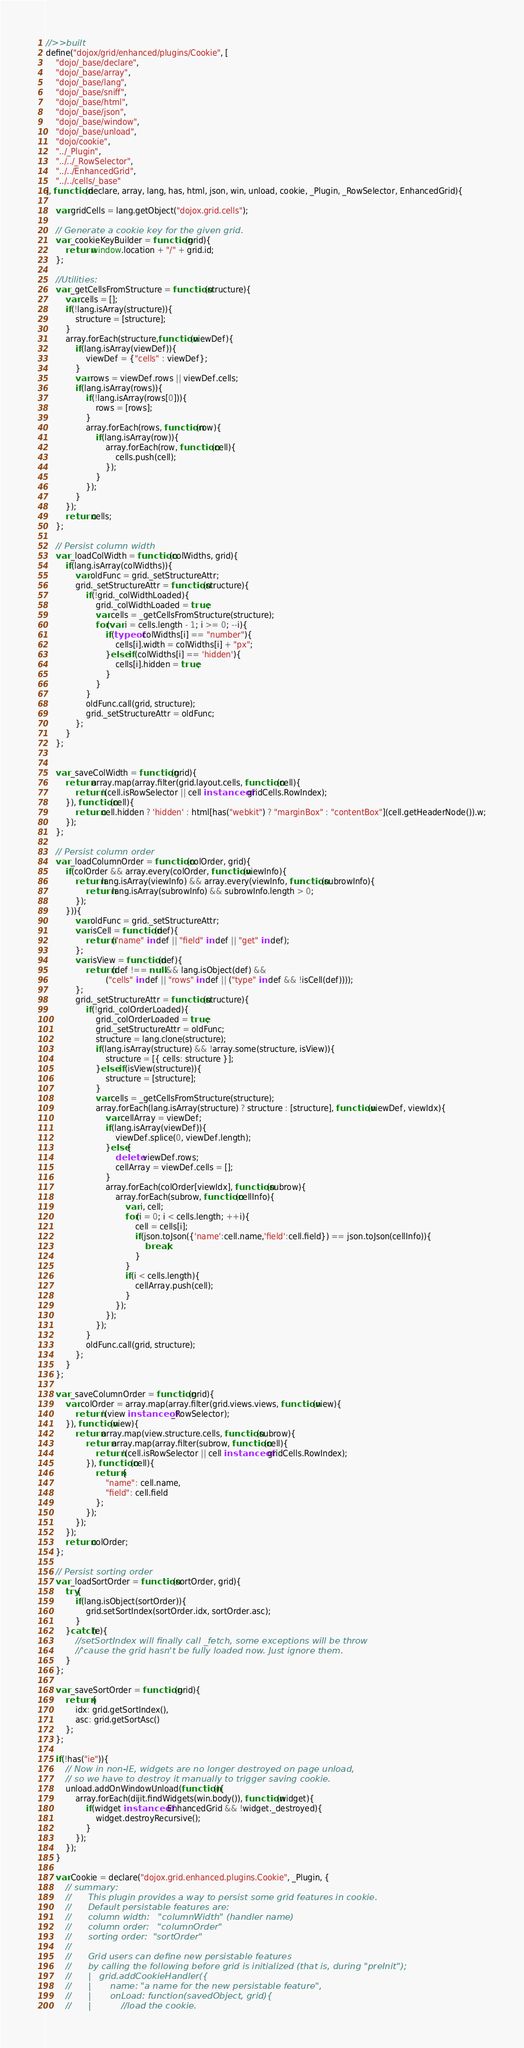Convert code to text. <code><loc_0><loc_0><loc_500><loc_500><_JavaScript_>//>>built
define("dojox/grid/enhanced/plugins/Cookie", [
	"dojo/_base/declare",
	"dojo/_base/array",
	"dojo/_base/lang",
	"dojo/_base/sniff",
	"dojo/_base/html",
	"dojo/_base/json",
	"dojo/_base/window",
	"dojo/_base/unload",
	"dojo/cookie",
	"../_Plugin",
	"../../_RowSelector",
	"../../EnhancedGrid",
	"../../cells/_base"
], function(declare, array, lang, has, html, json, win, unload, cookie, _Plugin, _RowSelector, EnhancedGrid){

	var gridCells = lang.getObject("dojox.grid.cells");

	// Generate a cookie key for the given grid.
	var _cookieKeyBuilder = function(grid){
		return window.location + "/" + grid.id;
	};
	
	//Utilities:
	var _getCellsFromStructure = function(structure){
		var cells = [];
		if(!lang.isArray(structure)){
			structure = [structure];
		}
		array.forEach(structure,function(viewDef){
			if(lang.isArray(viewDef)){
				viewDef = {"cells" : viewDef};
			}
			var rows = viewDef.rows || viewDef.cells;
			if(lang.isArray(rows)){
				if(!lang.isArray(rows[0])){
					rows = [rows];
				}
				array.forEach(rows, function(row){
					if(lang.isArray(row)){
						array.forEach(row, function(cell){
							cells.push(cell);
						});
					}
				});
			}
		});
		return cells;
	};
	
	// Persist column width
	var _loadColWidth = function(colWidths, grid){
		if(lang.isArray(colWidths)){
			var oldFunc = grid._setStructureAttr;
			grid._setStructureAttr = function(structure){
				if(!grid._colWidthLoaded){
					grid._colWidthLoaded = true;
					var cells = _getCellsFromStructure(structure);
					for(var i = cells.length - 1; i >= 0; --i){
						if(typeof colWidths[i] == "number"){
							cells[i].width = colWidths[i] + "px";
						}else if(colWidths[i] == 'hidden'){
							cells[i].hidden = true;
						}
					}
				}
				oldFunc.call(grid, structure);
				grid._setStructureAttr = oldFunc;
			};
		}
	};
	

	var _saveColWidth = function(grid){
		return array.map(array.filter(grid.layout.cells, function(cell){
			return !(cell.isRowSelector || cell instanceof gridCells.RowIndex);
		}), function(cell){
			return cell.hidden ? 'hidden' : html[has("webkit") ? "marginBox" : "contentBox"](cell.getHeaderNode()).w;
		});
	};
	
	// Persist column order
	var _loadColumnOrder = function(colOrder, grid){
		if(colOrder && array.every(colOrder, function(viewInfo){
			return lang.isArray(viewInfo) && array.every(viewInfo, function(subrowInfo){
				return lang.isArray(subrowInfo) && subrowInfo.length > 0;
			});
		})){
			var oldFunc = grid._setStructureAttr;
			var isCell = function(def){
				return ("name" in def || "field" in def || "get" in def);
			};
			var isView = function(def){
				return (def !== null && lang.isObject(def) &&
						("cells" in def || "rows" in def || ("type" in def && !isCell(def))));
			};
			grid._setStructureAttr = function(structure){
				if(!grid._colOrderLoaded){
					grid._colOrderLoaded = true;
					grid._setStructureAttr = oldFunc;
					structure = lang.clone(structure);
					if(lang.isArray(structure) && !array.some(structure, isView)){
						structure = [{ cells: structure }];
					}else if(isView(structure)){
						structure = [structure];
					}
					var cells = _getCellsFromStructure(structure);
					array.forEach(lang.isArray(structure) ? structure : [structure], function(viewDef, viewIdx){
						var cellArray = viewDef;
						if(lang.isArray(viewDef)){
							viewDef.splice(0, viewDef.length);
						}else{
							delete viewDef.rows;
							cellArray = viewDef.cells = [];
						}
						array.forEach(colOrder[viewIdx], function(subrow){
							array.forEach(subrow, function(cellInfo){
								var i, cell;
								for(i = 0; i < cells.length; ++i){
									cell = cells[i];
									if(json.toJson({'name':cell.name,'field':cell.field}) == json.toJson(cellInfo)){
										break;
									}
								}
								if(i < cells.length){
									cellArray.push(cell);
								}
							});
						});
					});
				}
				oldFunc.call(grid, structure);
			};
		}
	};
	
	var _saveColumnOrder = function(grid){
		var colOrder = array.map(array.filter(grid.views.views, function(view){
			return !(view instanceof _RowSelector);
		}), function(view){
			return array.map(view.structure.cells, function(subrow){
				return array.map(array.filter(subrow, function(cell){
					return !(cell.isRowSelector || cell instanceof gridCells.RowIndex);
				}), function(cell){
					return {
						"name": cell.name,
						"field": cell.field
					};
				});
			});
		});
		return colOrder;
	};
	
	// Persist sorting order
	var _loadSortOrder = function(sortOrder, grid){
		try{
			if(lang.isObject(sortOrder)){
				grid.setSortIndex(sortOrder.idx, sortOrder.asc);
			}
		}catch(e){
			//setSortIndex will finally call _fetch, some exceptions will be throw
			//'cause the grid hasn't be fully loaded now. Just ignore them.
		}
	};
	
	var _saveSortOrder = function(grid){
		return {
			idx: grid.getSortIndex(),
			asc: grid.getSortAsc()
		};
	};
	
	if(!has("ie")){
		// Now in non-IE, widgets are no longer destroyed on page unload,
		// so we have to destroy it manually to trigger saving cookie.
		unload.addOnWindowUnload(function(){
			array.forEach(dijit.findWidgets(win.body()), function(widget){
				if(widget instanceof EnhancedGrid && !widget._destroyed){
					widget.destroyRecursive();
				}
			});
		});
	}
	
	var Cookie = declare("dojox.grid.enhanced.plugins.Cookie", _Plugin, {
		// summary:
		//		This plugin provides a way to persist some grid features in cookie.
		//		Default persistable features are:
		//		column width:	"columnWidth" (handler name)
		//		column order:	"columnOrder"
		//		sorting order:	"sortOrder"
		//
		//		Grid users can define new persistable features
		//		by calling the following before grid is initialized (that is, during "preInit");
		//		|	grid.addCookieHandler({
		//		|		name: "a name for the new persistable feature",
		//		|		onLoad: function(savedObject, grid){
		//		|			//load the cookie.</code> 